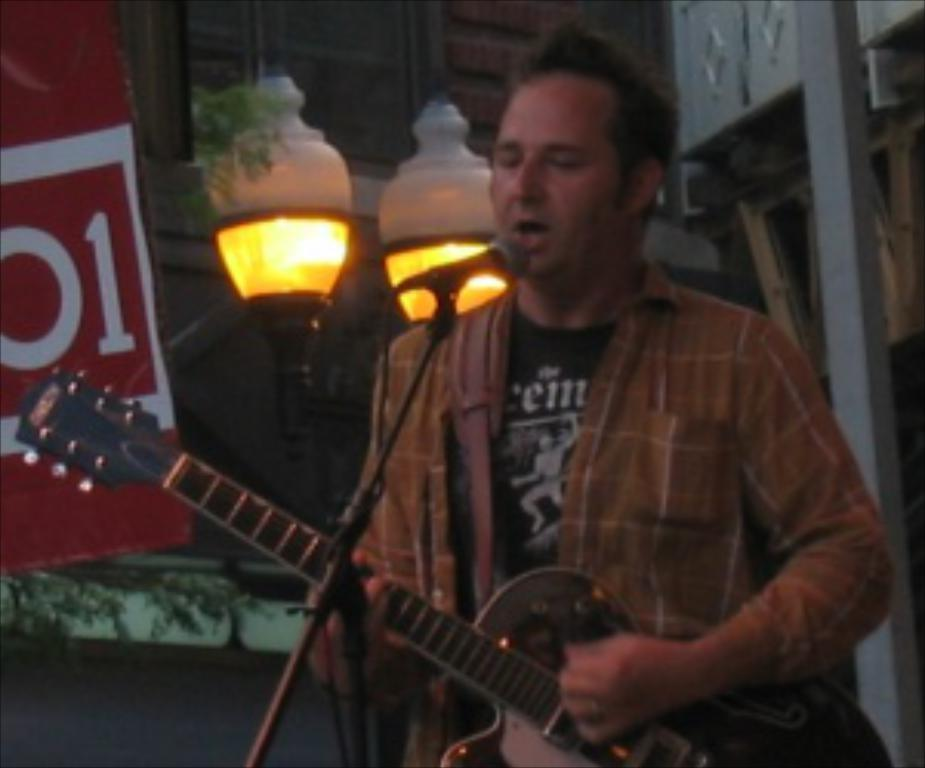What type of space is depicted in the image? The image contains a room. What lighting fixtures are present in the room? There are two big lamps in the room. What activity is the person in the room engaged in? The person is playing the guitar and singing in the room. What is the position of the person's mouth while singing? The person's mouth is open. What color is the person's t-shirt? The person is wearing a black t-shirt. What color is the person's shirt? The person is wearing a brown shirt. Can you see a basin in the room where the person is playing the guitar? There is no basin visible in the image; it only shows a room with a person playing the guitar and singing. 